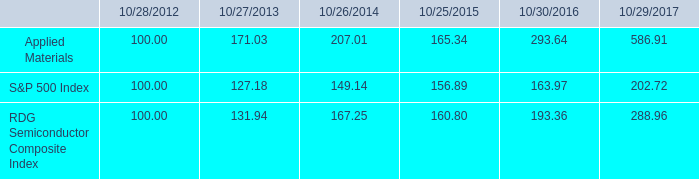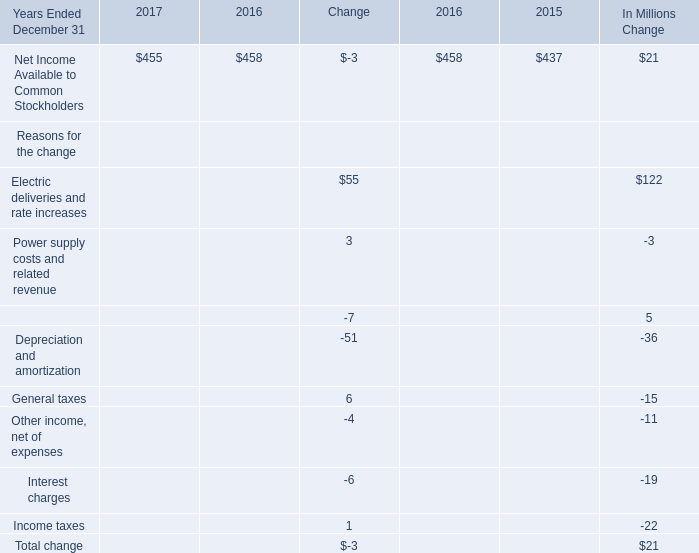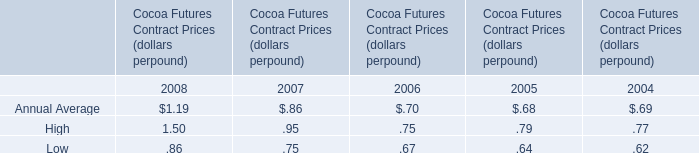how much percent did the investor make on applied materials from the first 5 years compared to the 2016 to 2017 time period ? ( not including compound interest ) 
Computations: ((293.64 - 100) - ((586.91 - 293.64) / 293.64))
Answer: 192.64126. 